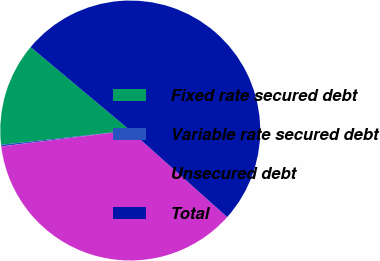<chart> <loc_0><loc_0><loc_500><loc_500><pie_chart><fcel>Fixed rate secured debt<fcel>Variable rate secured debt<fcel>Unsecured debt<fcel>Total<nl><fcel>12.85%<fcel>0.21%<fcel>36.44%<fcel>50.5%<nl></chart> 